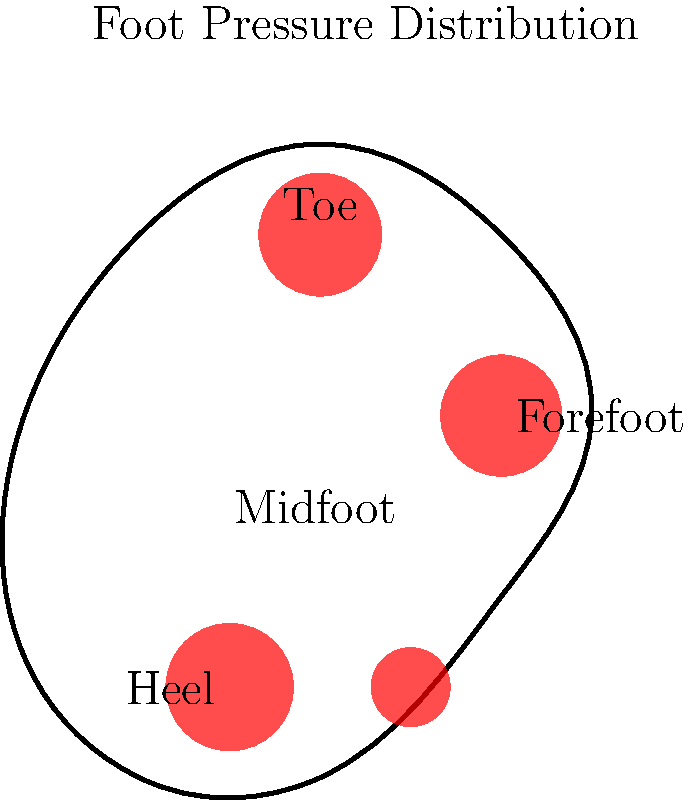In visualizing the pressure distribution on a foot during different phases of gait using VTK with Node.js, which data structure would be most appropriate for representing the varying pressure intensities across the foot surface, and how would you map this data to a color scale for effective visualization? To visualize the pressure distribution on a foot during different gait phases using VTK with Node.js, we need to consider the following steps:

1. Data Structure:
   - Use a 2D array or grid to represent the foot surface.
   - Each element in the array corresponds to a point on the foot and stores the pressure value.
   - The dimensions of the array should match the resolution of the foot model.

2. Pressure Data:
   - Collect pressure data for different points on the foot during various gait phases.
   - Store these values in the 2D array, updating them for each phase of the gait cycle.

3. VTK Data Representation:
   - Convert the 2D array to a vtkImageData or vtkStructuredGrid object.
   - This allows VTK to interpret the data as a 2D surface with associated scalar values (pressure).

4. Color Mapping:
   - Create a vtkLookupTable to map pressure values to colors.
   - Define a color scale, e.g., blue for low pressure to red for high pressure.
   - Use vtkColorTransferFunction to create a smooth transition between colors.

5. Visualization:
   - Apply the color mapping to the data using vtkMapperr.
   - Create a vtkActor to represent the foot surface in the 3D scene.
   - Use vtkRenderer to render the scene and vtkRenderWindow for display.

6. Interactivity:
   - Implement controls to switch between different gait phases.
   - Update the pressure data and refresh the visualization for each phase.

7. Node.js Integration:
   - Use a Node.js VTK binding library (e.g., vtk.js) to interface with VTK.
   - Create a server to handle data processing and serve the visualization to a web client.

The most appropriate data structure for representing varying pressure intensities would be a 2D array or grid, as it naturally maps to the foot surface and can be easily converted to VTK data objects. The color mapping using vtkLookupTable and vtkColorTransferFunction allows for effective visualization of pressure intensities.
Answer: 2D array with vtkLookupTable for color mapping 